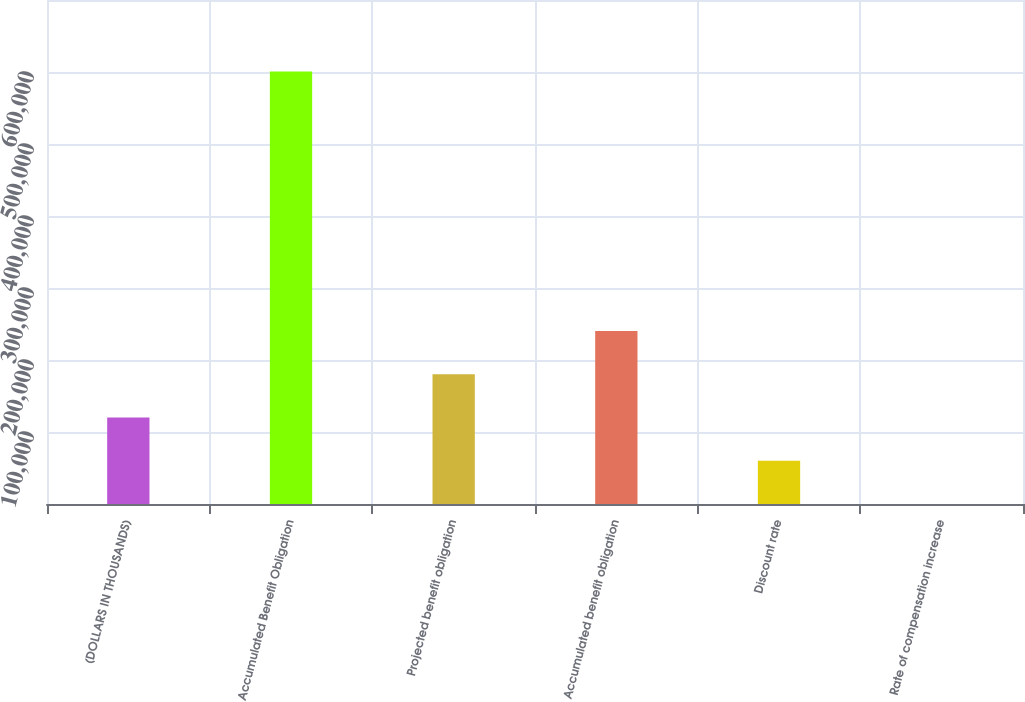Convert chart. <chart><loc_0><loc_0><loc_500><loc_500><bar_chart><fcel>(DOLLARS IN THOUSANDS)<fcel>Accumulated Benefit Obligation<fcel>Projected benefit obligation<fcel>Accumulated benefit obligation<fcel>Discount rate<fcel>Rate of compensation increase<nl><fcel>120129<fcel>600634<fcel>180192<fcel>240256<fcel>60066.3<fcel>3.25<nl></chart> 